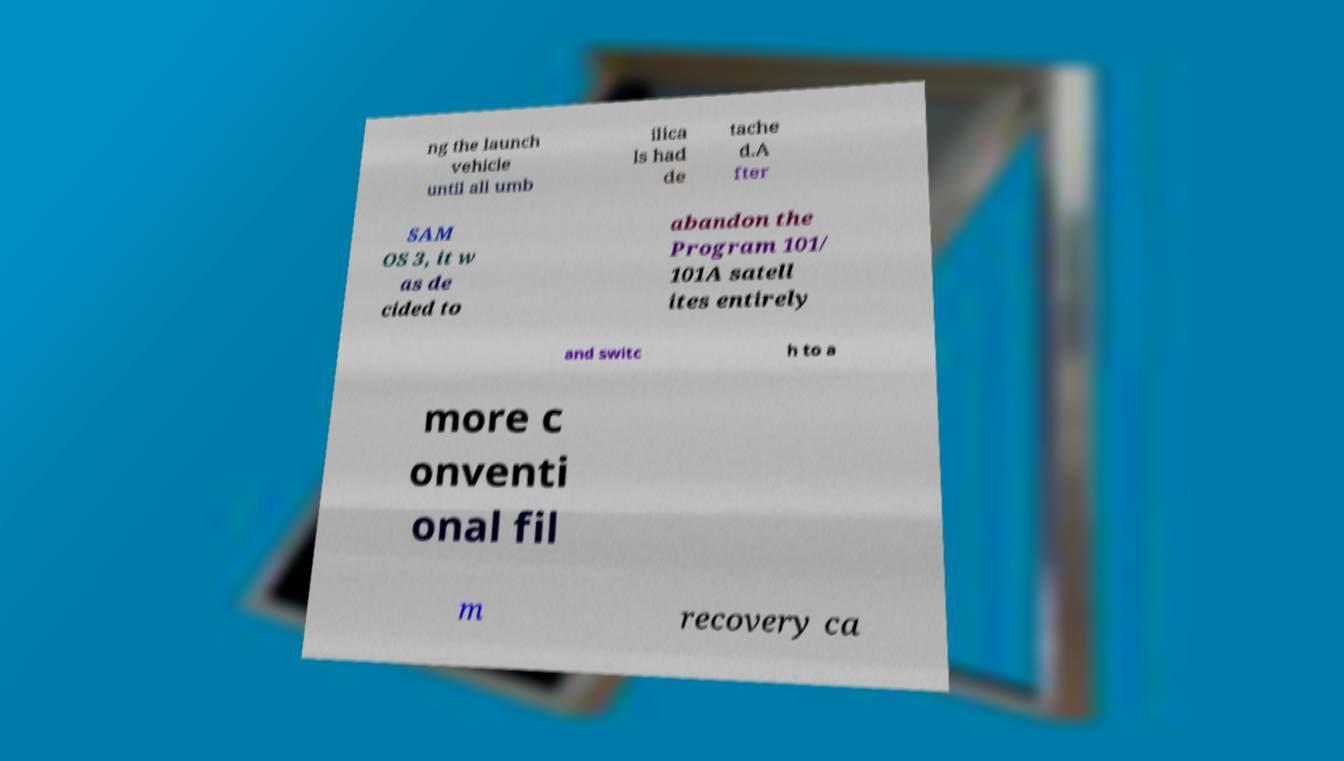Can you read and provide the text displayed in the image?This photo seems to have some interesting text. Can you extract and type it out for me? ng the launch vehicle until all umb ilica ls had de tache d.A fter SAM OS 3, it w as de cided to abandon the Program 101/ 101A satell ites entirely and switc h to a more c onventi onal fil m recovery ca 